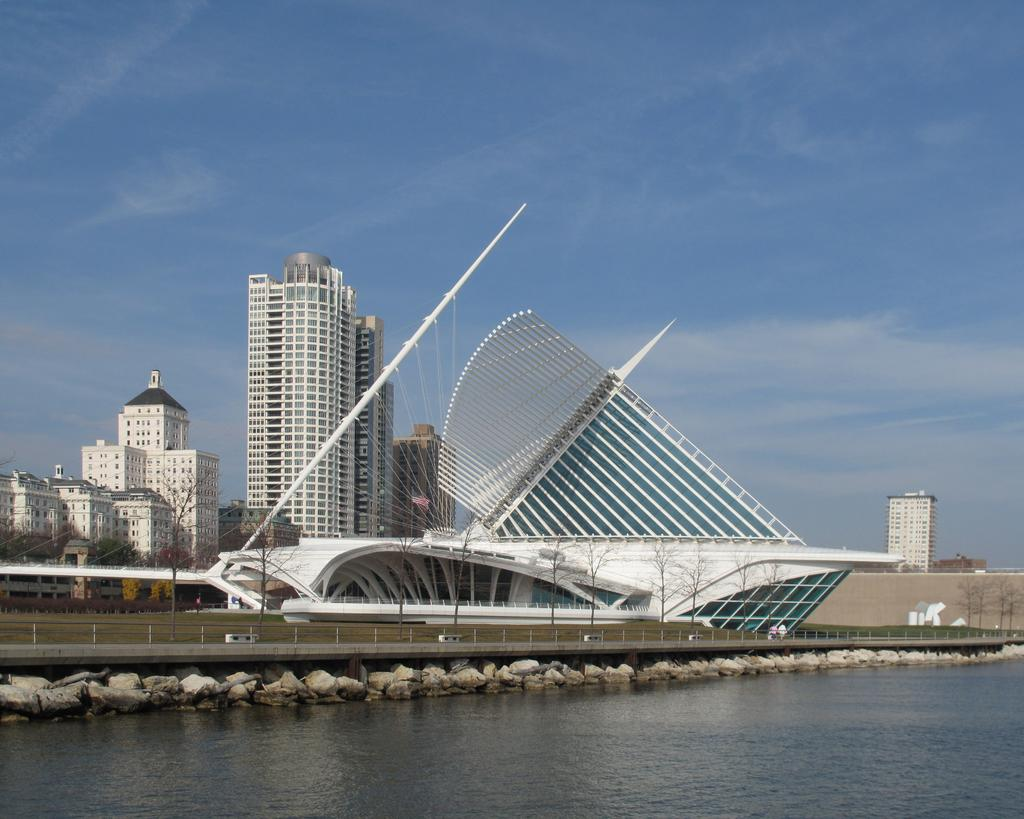What is the primary element visible in the image? There is water in the image. What other objects or features can be seen in the image? There are stones, persons on a bridge, grass, buildings, trees, and the sky visible in the image. Can you describe the setting of the image? The image features a bridge over water, surrounded by grass, trees, and buildings. What is visible at the top of the image? The sky is visible at the top of the image. How many screws can be seen in the image? There are no screws visible in the image. 